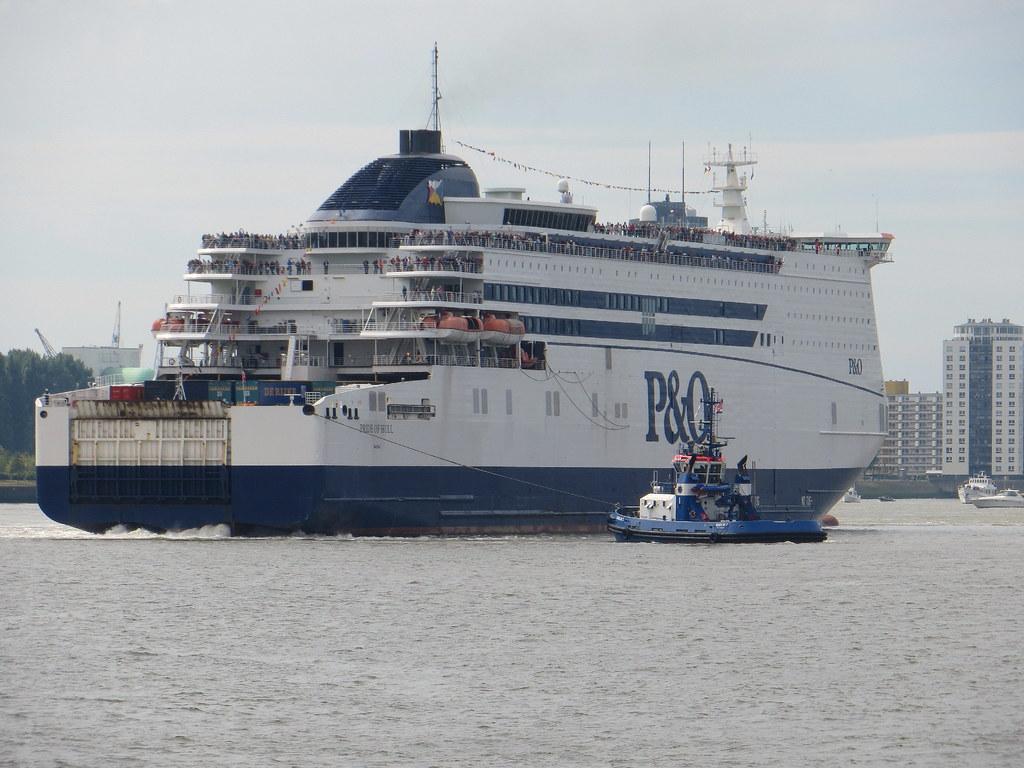What letters are found on the ship in big font?
Your answer should be compact. P&o. 